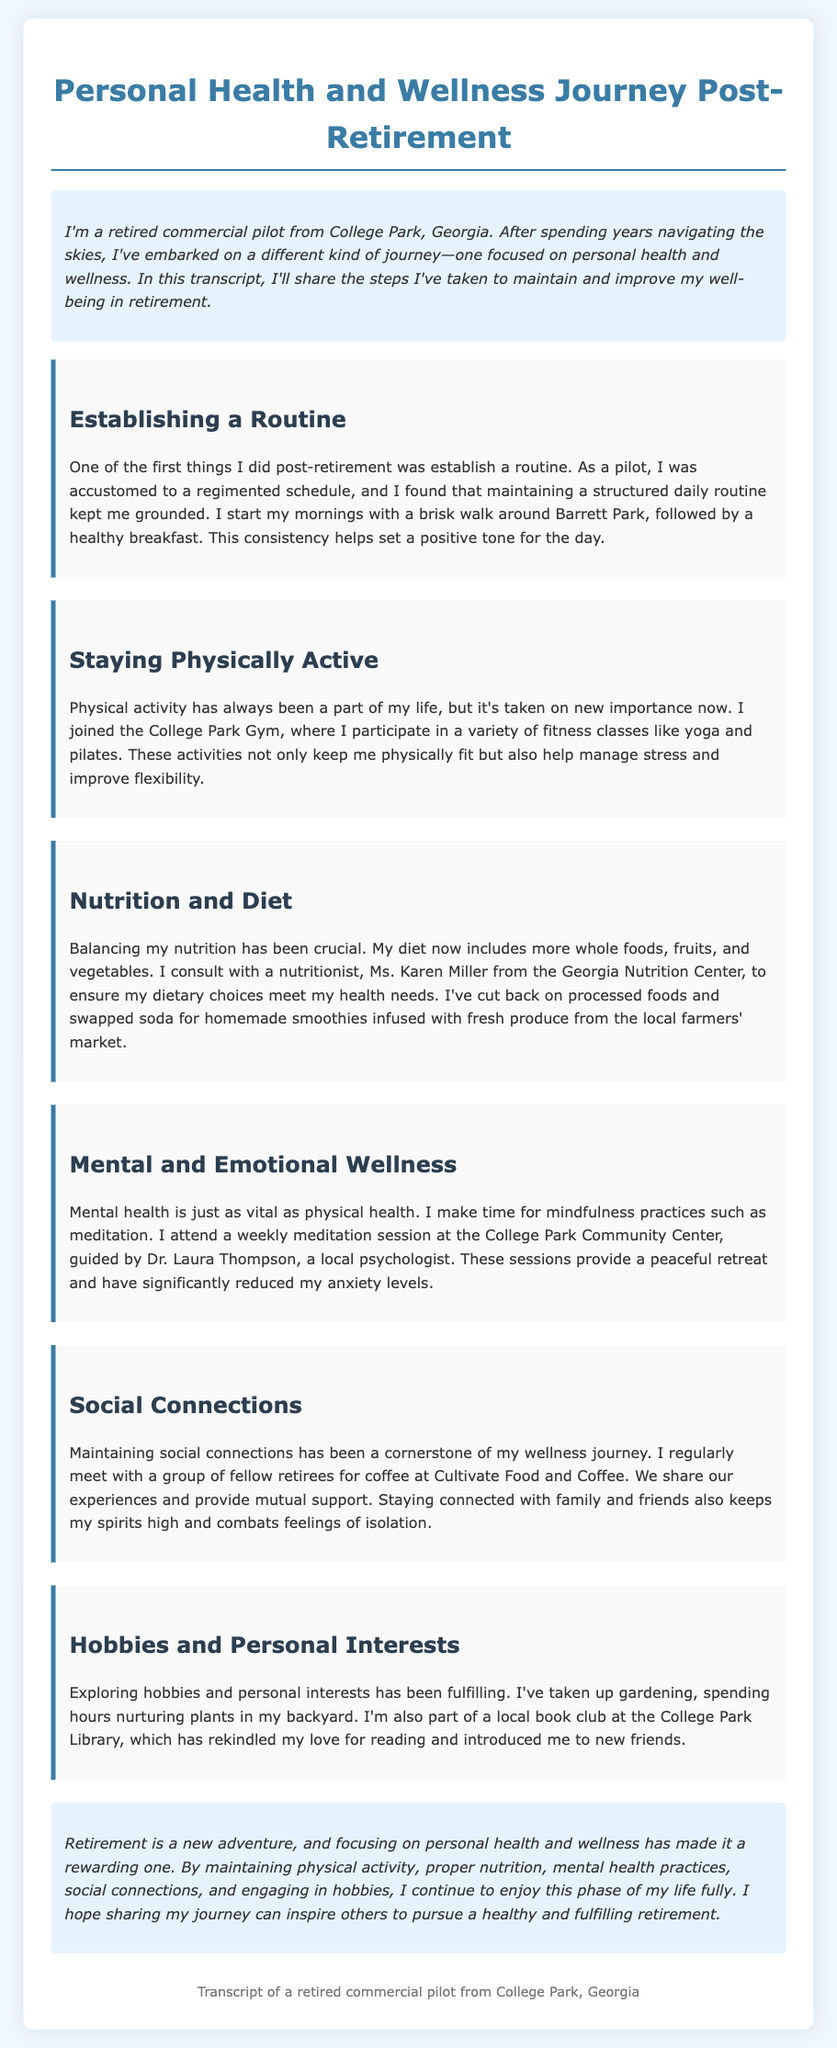What is the name of the nutritionist mentioned? The nutritionist's name is mentioned as Ms. Karen Miller.
Answer: Ms. Karen Miller How often does the pilot attend meditation sessions? The document states that he attends a weekly meditation session.
Answer: Weekly What type of fitness classes does the pilot participate in? The pilot mentions participating in yoga and pilates classes at the gym.
Answer: Yoga and pilates Where does the pilot have coffee with fellow retirees? The document specifies that he meets with fellow retirees at Cultivate Food and Coffee.
Answer: Cultivate Food and Coffee What is one of the hobbies the pilot has taken up? The pilot discusses gardening as one of his hobbies.
Answer: Gardening What is the purpose of the weekly meditation sessions? The meditation sessions are described as a peaceful retreat that reduces anxiety levels.
Answer: Reduce anxiety What is the main health focus of the pilot's journey? The pilot emphasizes personal health and wellness as the primary focus of his journey.
Answer: Personal health and wellness How does the pilot start his mornings? He begins his mornings with a brisk walk around Barrett Park.
Answer: Brisk walk around Barrett Park What city is the pilot from? The pilot states he is from College Park, Georgia.
Answer: College Park, Georgia What type of document is this? This document is a transcript detailing the pilot's health and wellness journey.
Answer: Transcript 